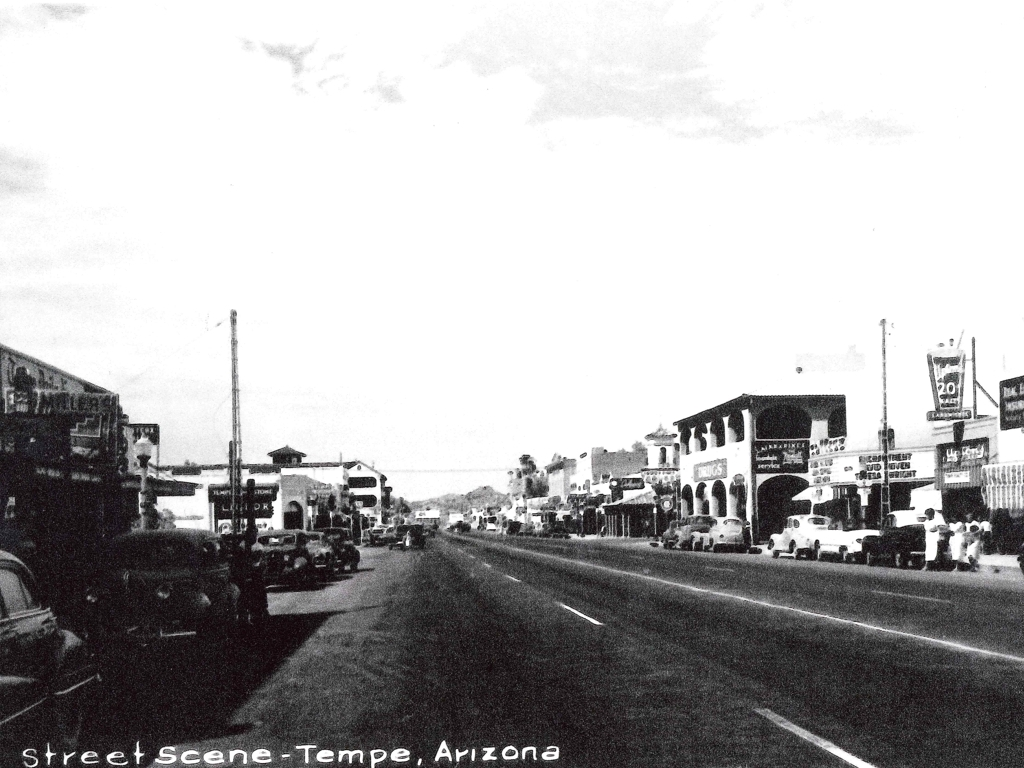How does this street scene reflect the social life of the time? This street scene captures a slice of social life that was common in smaller American towns. The prominent presence of automobiles indicates the increased mobility and independence that cars brought to people. Meanwhile, the array of storefronts suggests a time when local businesses were social hubs, where people would run into neighbors and exchange news. Such street scenes also hint at a post-war economic boom, with an air of optimism visible in the bustling street activity. 